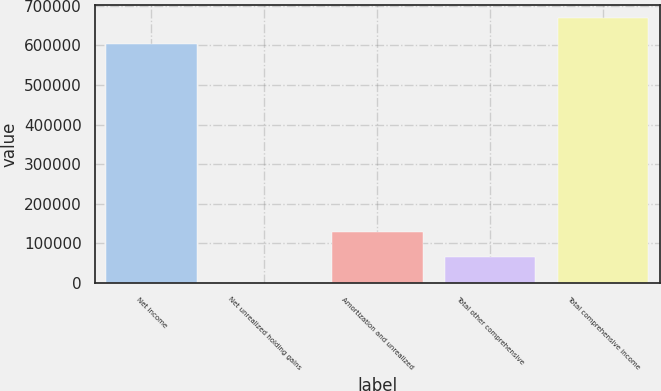Convert chart. <chart><loc_0><loc_0><loc_500><loc_500><bar_chart><fcel>Net income<fcel>Net unrealized holding gains<fcel>Amortization and unrealized<fcel>Total other comprehensive<fcel>Total comprehensive income<nl><fcel>603064<fcel>395<fcel>129837<fcel>65116<fcel>667785<nl></chart> 